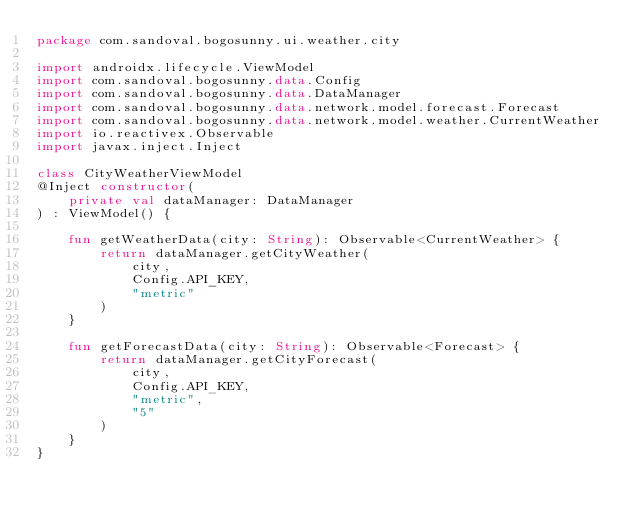Convert code to text. <code><loc_0><loc_0><loc_500><loc_500><_Kotlin_>package com.sandoval.bogosunny.ui.weather.city

import androidx.lifecycle.ViewModel
import com.sandoval.bogosunny.data.Config
import com.sandoval.bogosunny.data.DataManager
import com.sandoval.bogosunny.data.network.model.forecast.Forecast
import com.sandoval.bogosunny.data.network.model.weather.CurrentWeather
import io.reactivex.Observable
import javax.inject.Inject

class CityWeatherViewModel
@Inject constructor(
    private val dataManager: DataManager
) : ViewModel() {

    fun getWeatherData(city: String): Observable<CurrentWeather> {
        return dataManager.getCityWeather(
            city,
            Config.API_KEY,
            "metric"
        )
    }

    fun getForecastData(city: String): Observable<Forecast> {
        return dataManager.getCityForecast(
            city,
            Config.API_KEY,
            "metric",
            "5"
        )
    }
}</code> 